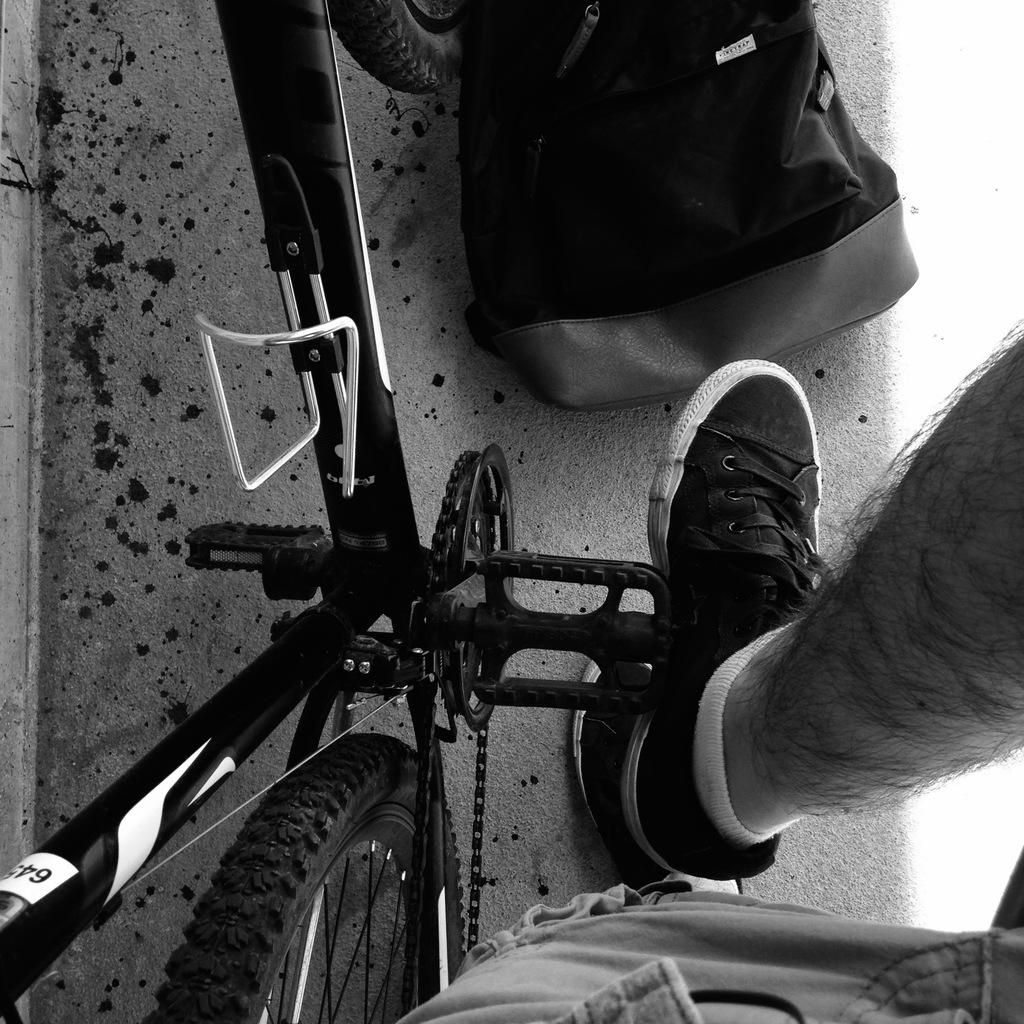What is the main subject of the picture? The main subject of the picture is a truncated image of a cycle. Can you describe any other elements in the picture? Yes, a leg of a person is visible in the picture. What is placed on top of the picture? There is a bag on top of the picture. What can be seen in the background of the picture? There is a path visible in the picture. What type of metal can be seen emitting smoke in the picture? There is no metal or smoke present in the picture; it features a truncated image of a cycle, a leg, a bag, and a path. 